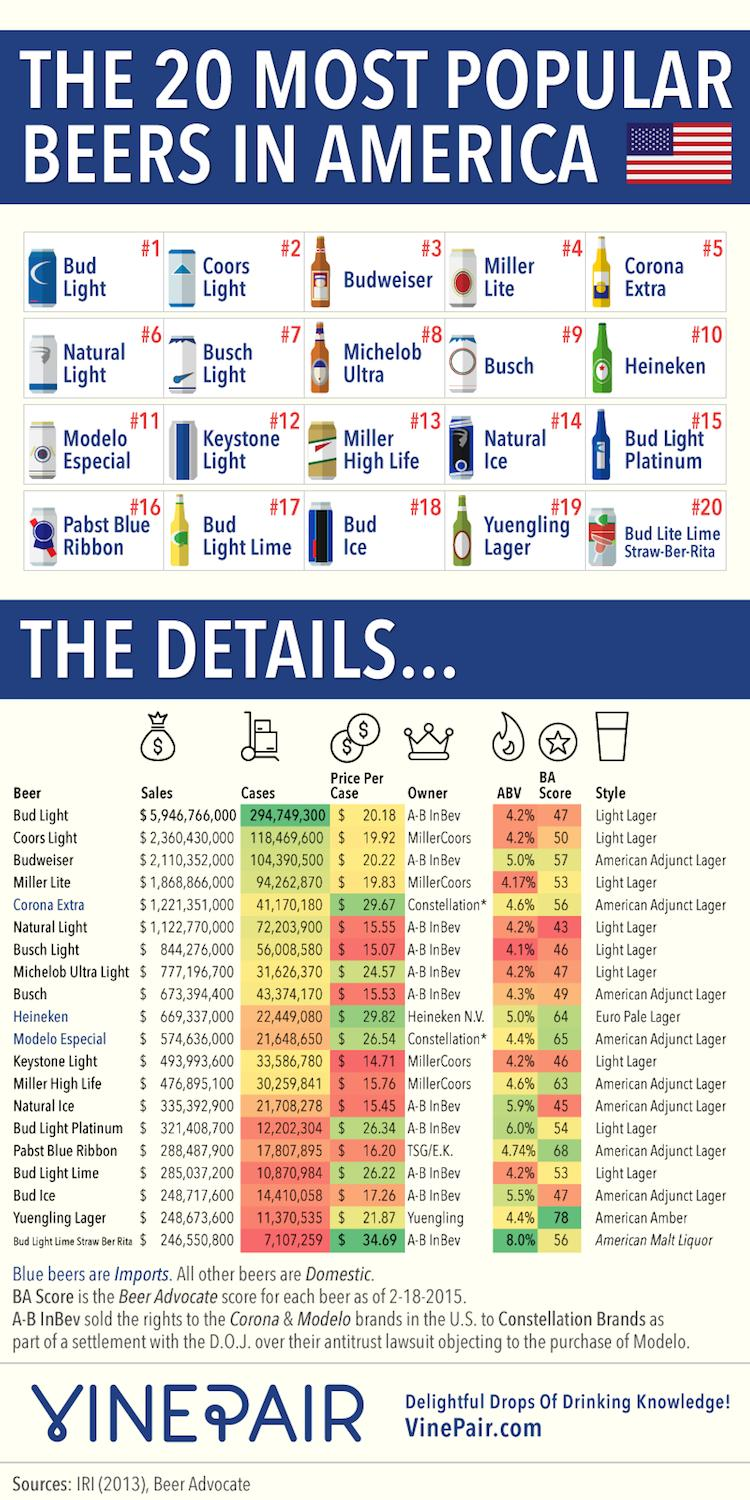Give some essential details in this illustration. In total, Coors Light and Heineken accounted for 14,091,8680 cases in 2020. There are two beer bottles in the second row. In the third row, there are four beer cans. AB InBev is the owner of Busch and Natural Ice beers. The BA score of natural light is 43. 